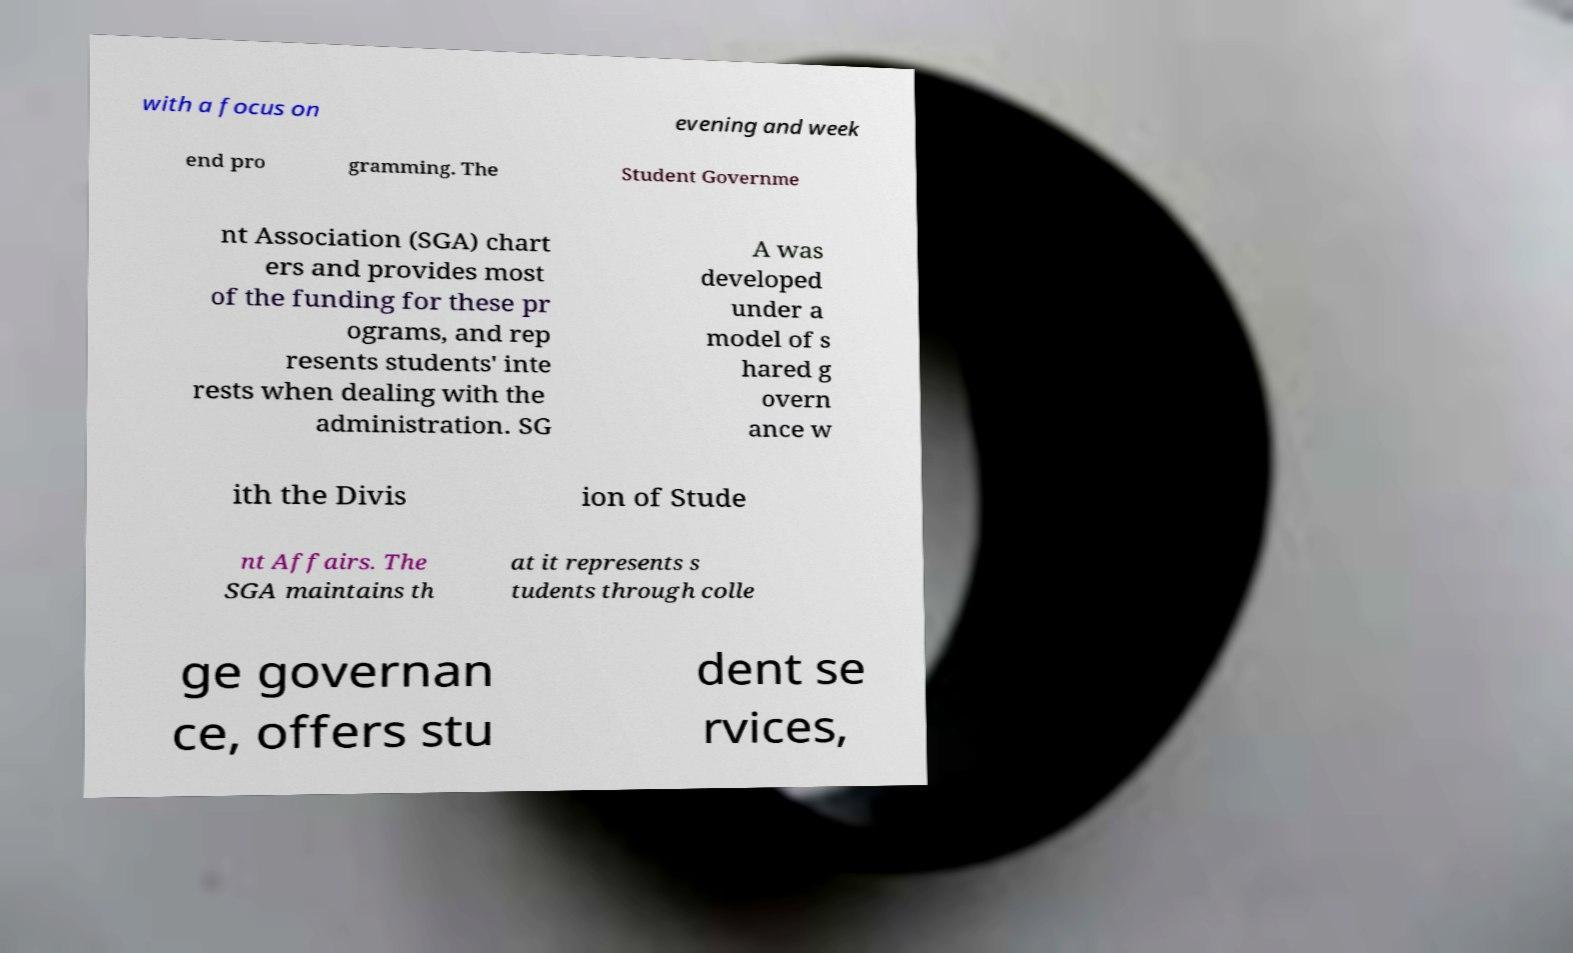Please identify and transcribe the text found in this image. with a focus on evening and week end pro gramming. The Student Governme nt Association (SGA) chart ers and provides most of the funding for these pr ograms, and rep resents students' inte rests when dealing with the administration. SG A was developed under a model of s hared g overn ance w ith the Divis ion of Stude nt Affairs. The SGA maintains th at it represents s tudents through colle ge governan ce, offers stu dent se rvices, 